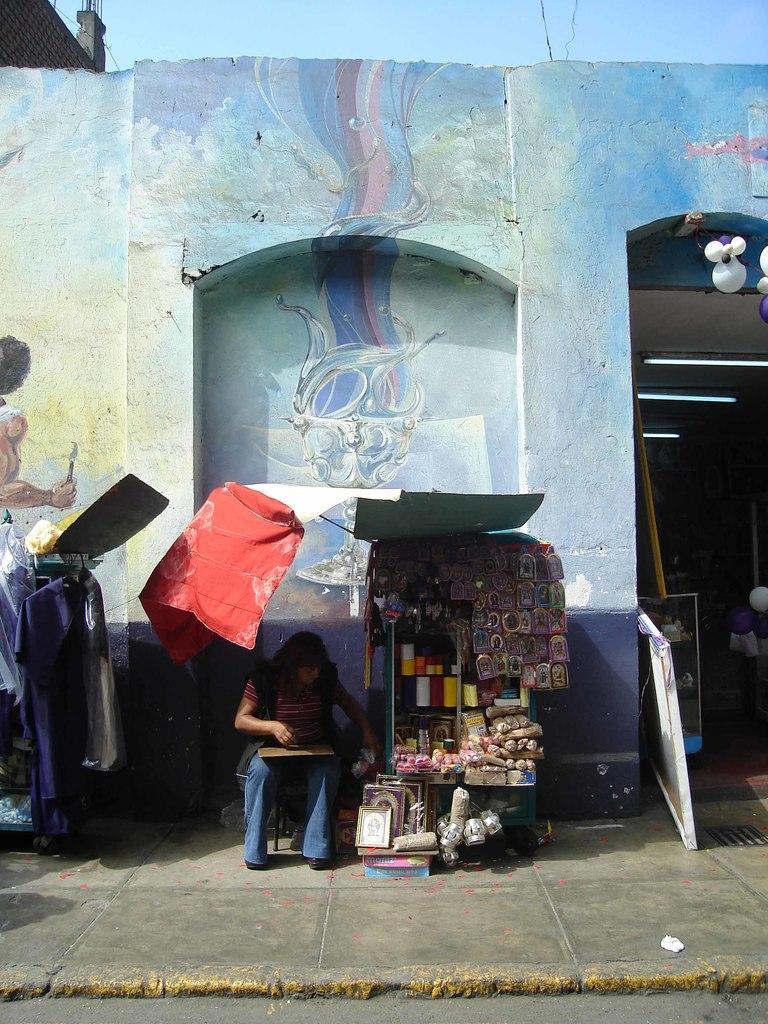Describe this image in one or two sentences. In the image there is a woman sitting in front of a wall with a small store beside her and there is an entrance on the right side and above its sky. 